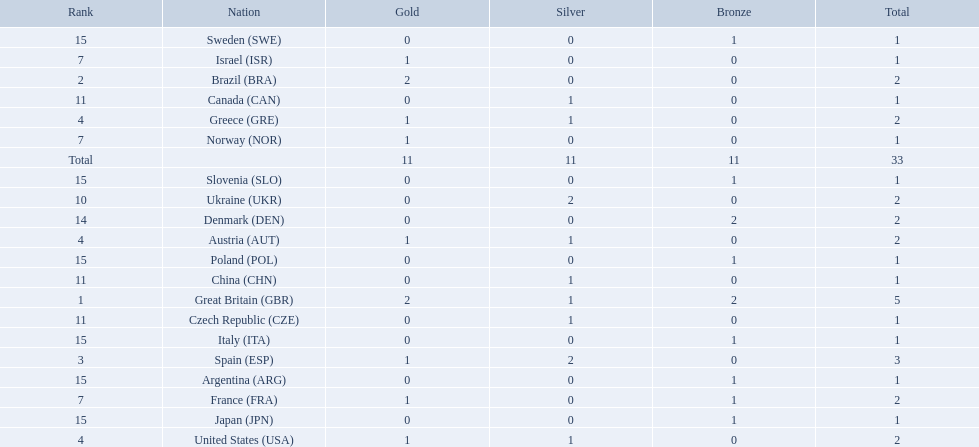Which nation received 2 silver medals? Spain (ESP), Ukraine (UKR). Of those, which nation also had 2 total medals? Spain (ESP). 